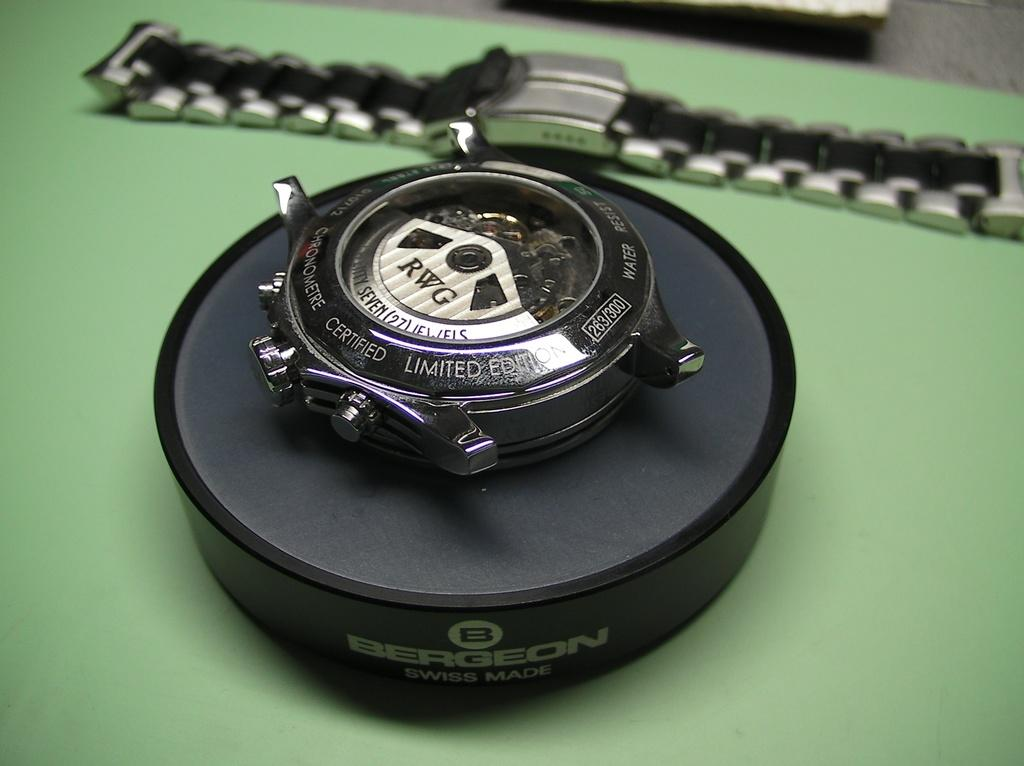<image>
Offer a succinct explanation of the picture presented. the word RWG that is on a black item 